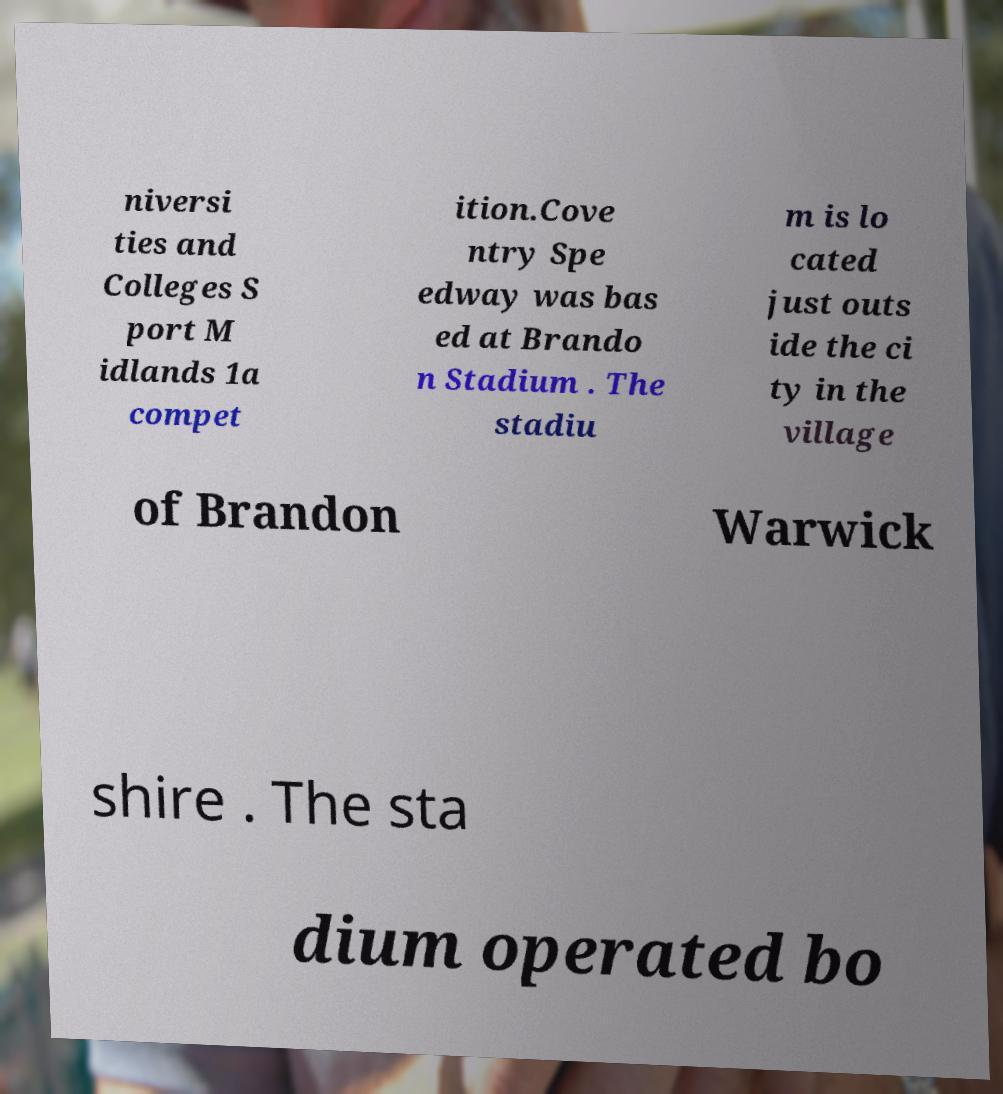There's text embedded in this image that I need extracted. Can you transcribe it verbatim? niversi ties and Colleges S port M idlands 1a compet ition.Cove ntry Spe edway was bas ed at Brando n Stadium . The stadiu m is lo cated just outs ide the ci ty in the village of Brandon Warwick shire . The sta dium operated bo 